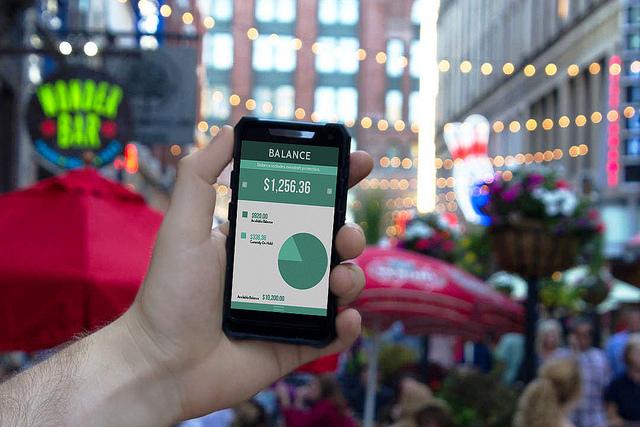How many limbs are shown?
Keep it brief. 1. Does the word "balance" in the photo refer to a scale?
Concise answer only. No. What kind of graph or chart is shown?
Give a very brief answer. Pie. 